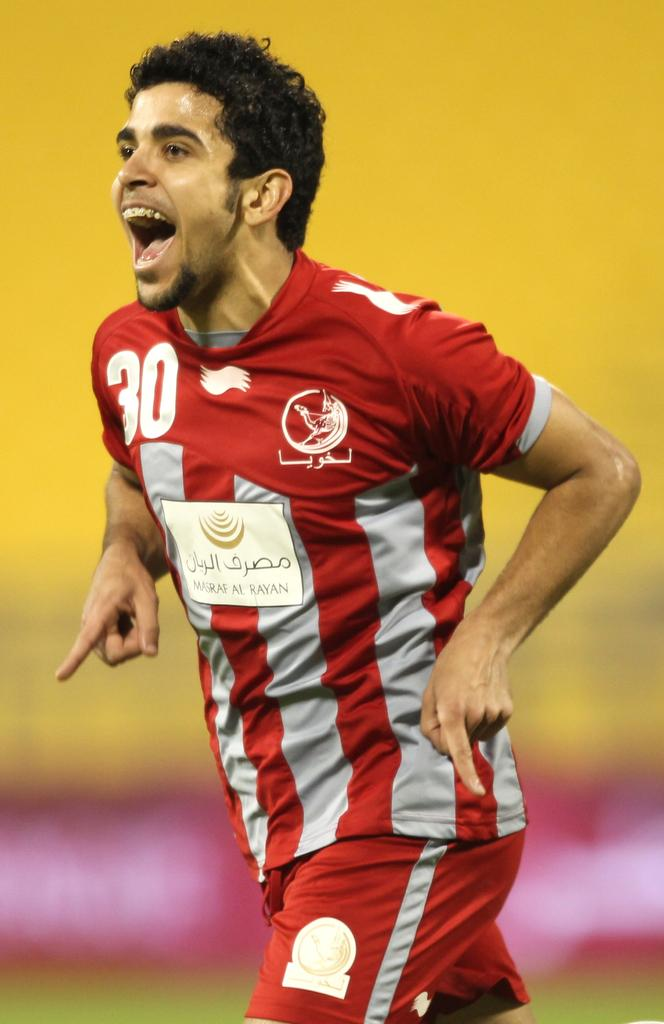<image>
Write a terse but informative summary of the picture. A man in a red and gray uniform has a 30 on the left top of the shirt 